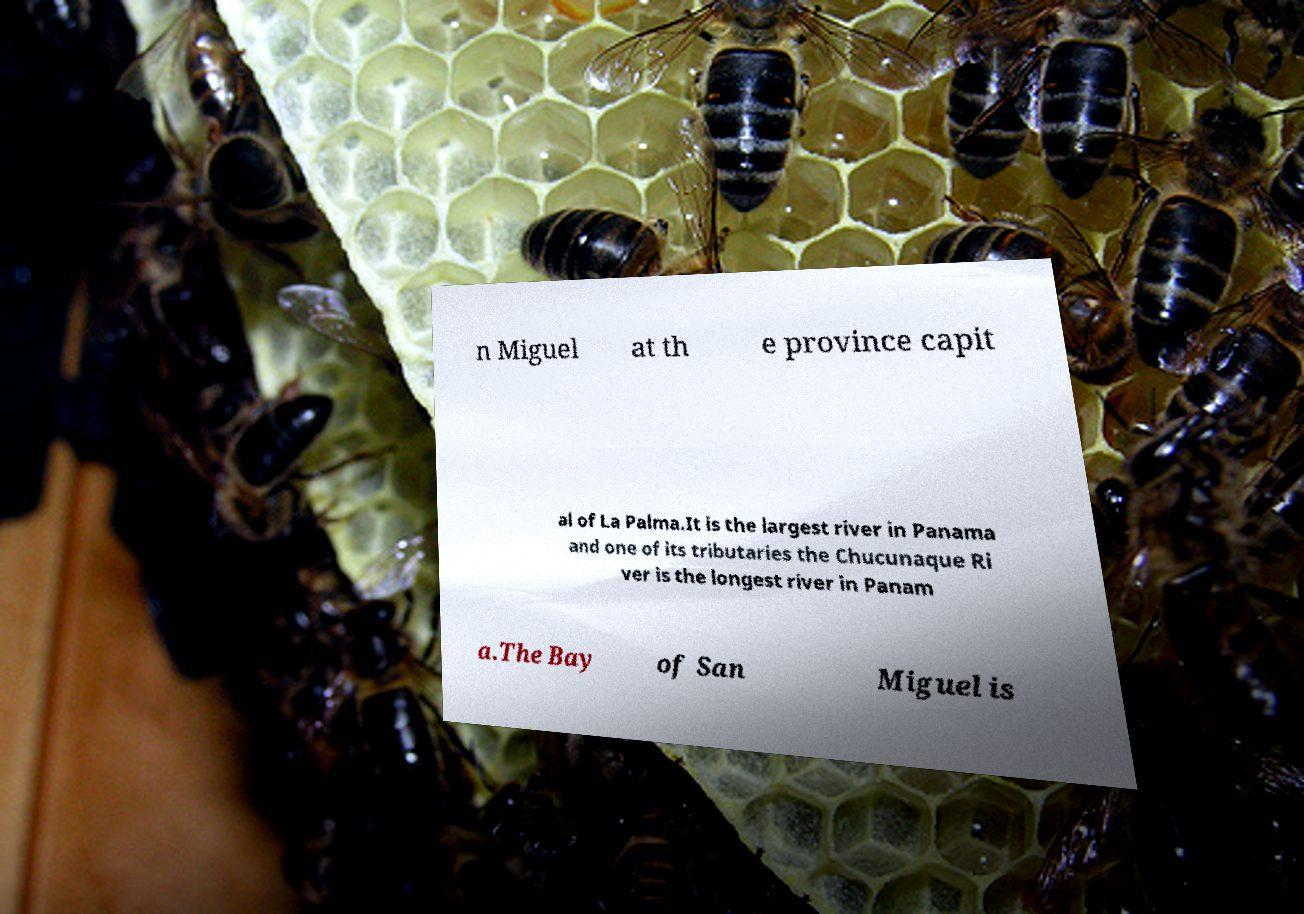For documentation purposes, I need the text within this image transcribed. Could you provide that? n Miguel at th e province capit al of La Palma.It is the largest river in Panama and one of its tributaries the Chucunaque Ri ver is the longest river in Panam a.The Bay of San Miguel is 